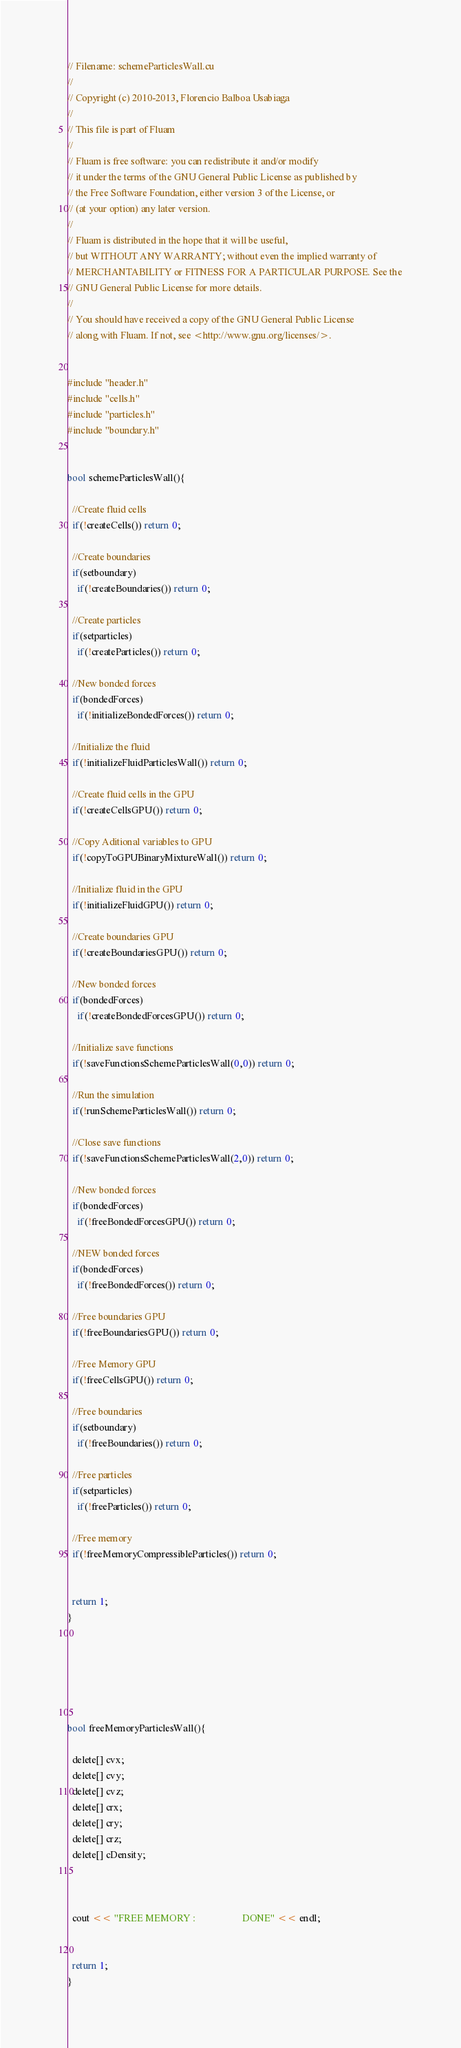Convert code to text. <code><loc_0><loc_0><loc_500><loc_500><_Cuda_>// Filename: schemeParticlesWall.cu
//
// Copyright (c) 2010-2013, Florencio Balboa Usabiaga
//
// This file is part of Fluam
//
// Fluam is free software: you can redistribute it and/or modify
// it under the terms of the GNU General Public License as published by
// the Free Software Foundation, either version 3 of the License, or
// (at your option) any later version.
//
// Fluam is distributed in the hope that it will be useful,
// but WITHOUT ANY WARRANTY; without even the implied warranty of
// MERCHANTABILITY or FITNESS FOR A PARTICULAR PURPOSE. See the
// GNU General Public License for more details.
//
// You should have received a copy of the GNU General Public License
// along with Fluam. If not, see <http://www.gnu.org/licenses/>.


#include "header.h"
#include "cells.h"
#include "particles.h"
#include "boundary.h"


bool schemeParticlesWall(){
  
  //Create fluid cells
  if(!createCells()) return 0;

  //Create boundaries
  if(setboundary)
    if(!createBoundaries()) return 0;

  //Create particles
  if(setparticles)
    if(!createParticles()) return 0;

  //New bonded forces
  if(bondedForces)
    if(!initializeBondedForces()) return 0;

  //Initialize the fluid
  if(!initializeFluidParticlesWall()) return 0;
  
  //Create fluid cells in the GPU
  if(!createCellsGPU()) return 0;
  
  //Copy Aditional variables to GPU
  if(!copyToGPUBinaryMixtureWall()) return 0;

  //Initialize fluid in the GPU
  if(!initializeFluidGPU()) return 0;

  //Create boundaries GPU
  if(!createBoundariesGPU()) return 0;

  //New bonded forces
  if(bondedForces)
    if(!createBondedForcesGPU()) return 0;

  //Initialize save functions
  if(!saveFunctionsSchemeParticlesWall(0,0)) return 0;

  //Run the simulation
  if(!runSchemeParticlesWall()) return 0;

  //Close save functions
  if(!saveFunctionsSchemeParticlesWall(2,0)) return 0;

  //New bonded forces
  if(bondedForces)
    if(!freeBondedForcesGPU()) return 0;

  //NEW bonded forces
  if(bondedForces)
    if(!freeBondedForces()) return 0;
   
  //Free boundaries GPU
  if(!freeBoundariesGPU()) return 0;

  //Free Memory GPU
  if(!freeCellsGPU()) return 0;
  
  //Free boundaries
  if(setboundary)
    if(!freeBoundaries()) return 0;

  //Free particles
  if(setparticles)
    if(!freeParticles()) return 0;
 
  //Free memory
  if(!freeMemoryCompressibleParticles()) return 0;
  

  return 1;
}






bool freeMemoryParticlesWall(){

  delete[] cvx;
  delete[] cvy;
  delete[] cvz;
  delete[] crx;
  delete[] cry;
  delete[] crz;
  delete[] cDensity;

  

  cout << "FREE MEMORY :                   DONE" << endl;


  return 1;
}


</code> 